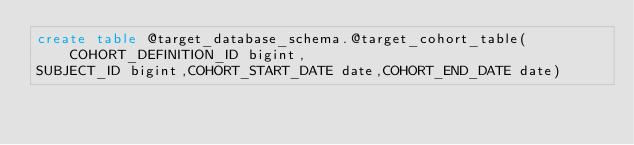Convert code to text. <code><loc_0><loc_0><loc_500><loc_500><_SQL_>create table @target_database_schema.@target_cohort_table(COHORT_DEFINITION_ID bigint,
SUBJECT_ID bigint,COHORT_START_DATE date,COHORT_END_DATE date)
</code> 